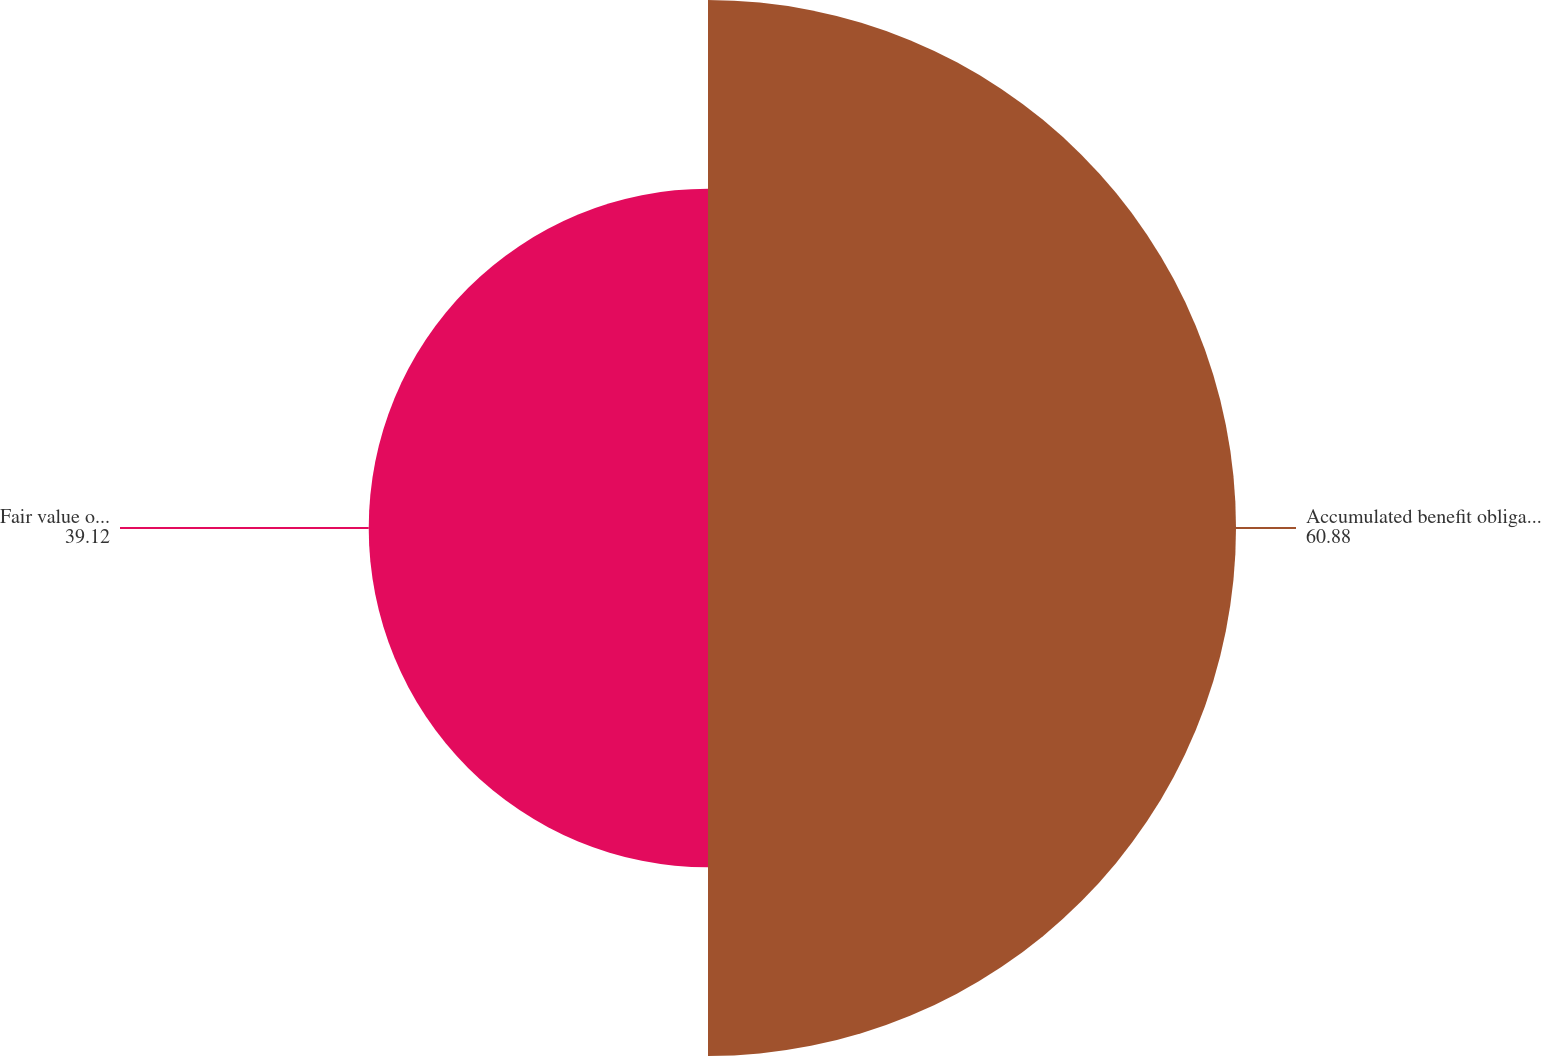Convert chart to OTSL. <chart><loc_0><loc_0><loc_500><loc_500><pie_chart><fcel>Accumulated benefit obligation<fcel>Fair value of plan assets<nl><fcel>60.88%<fcel>39.12%<nl></chart> 